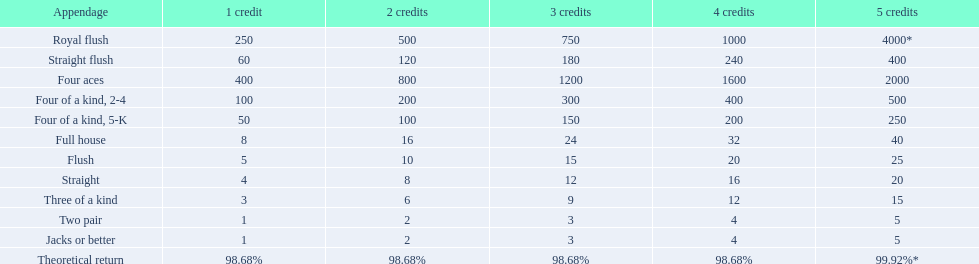What is the values in the 5 credits area? 4000*, 400, 2000, 500, 250, 40, 25, 20, 15, 5, 5. Which of these is for a four of a kind? 500, 250. What is the higher value? 500. What hand is this for Four of a kind, 2-4. 